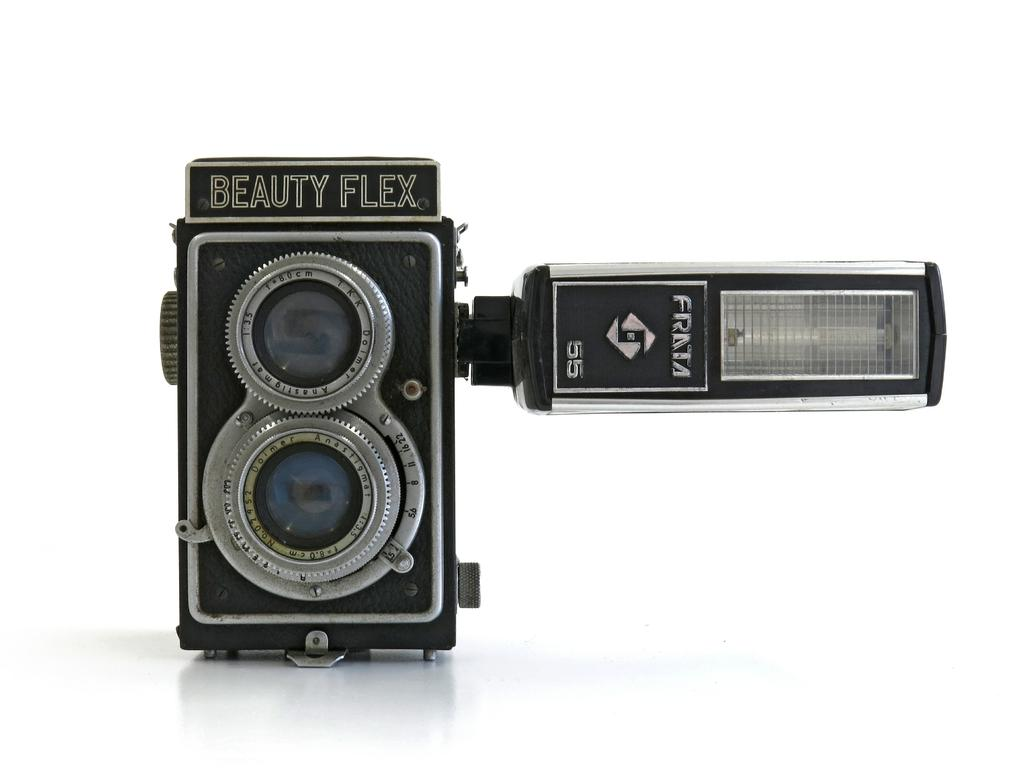<image>
Share a concise interpretation of the image provided. A camera, called a Beauty Flex, has a flash attached to it by Frata. 